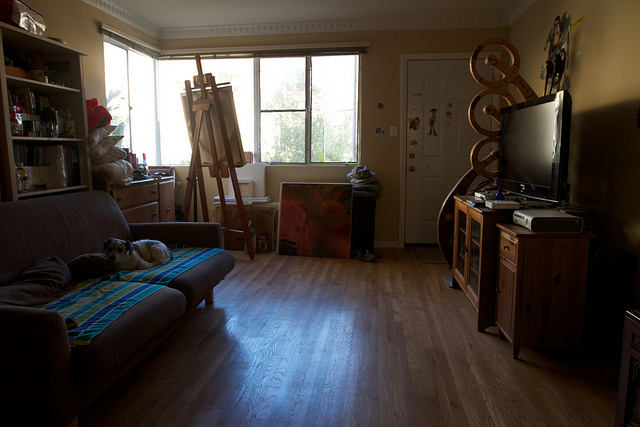What is likely on the item by the window?
A. food
B. painting
C. clothes
D. television
Answer with the option's letter from the given choices directly. The item by the window appears to display a colorful expression, which suggests it is option B, a painting. The bright colors and the structure visible on the canvas are characteristic of a painting rather than the other options listed. 